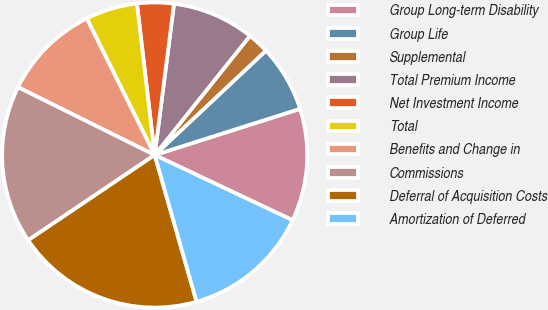Convert chart to OTSL. <chart><loc_0><loc_0><loc_500><loc_500><pie_chart><fcel>Group Long-term Disability<fcel>Group Life<fcel>Supplemental<fcel>Total Premium Income<fcel>Net Investment Income<fcel>Total<fcel>Benefits and Change in<fcel>Commissions<fcel>Deferral of Acquisition Costs<fcel>Amortization of Deferred<nl><fcel>11.93%<fcel>7.1%<fcel>2.27%<fcel>8.71%<fcel>3.88%<fcel>5.49%<fcel>10.32%<fcel>16.77%<fcel>19.99%<fcel>13.54%<nl></chart> 